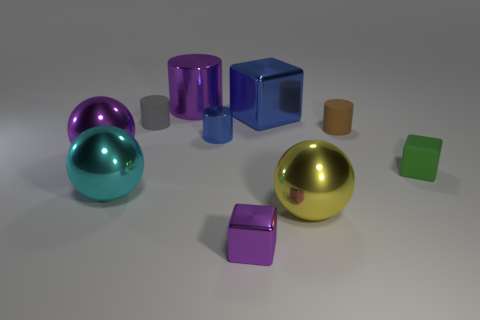How many other objects are there of the same material as the small blue cylinder?
Ensure brevity in your answer.  6. How many big metallic spheres are there?
Ensure brevity in your answer.  3. There is a tiny brown object that is the same shape as the gray matte object; what is it made of?
Offer a terse response. Rubber. Is the big purple thing to the left of the purple cylinder made of the same material as the brown thing?
Ensure brevity in your answer.  No. Is the number of big objects that are to the right of the small purple metallic thing greater than the number of small green objects on the left side of the large blue thing?
Offer a terse response. Yes. The cyan thing is what size?
Provide a succinct answer. Large. What shape is the brown object that is the same material as the tiny gray cylinder?
Keep it short and to the point. Cylinder. Do the purple metallic object that is behind the purple metal ball and the small blue metallic object have the same shape?
Keep it short and to the point. Yes. What number of things are either large purple metallic balls or large yellow balls?
Make the answer very short. 2. There is a block that is both in front of the brown object and behind the cyan sphere; what is its material?
Offer a very short reply. Rubber. 